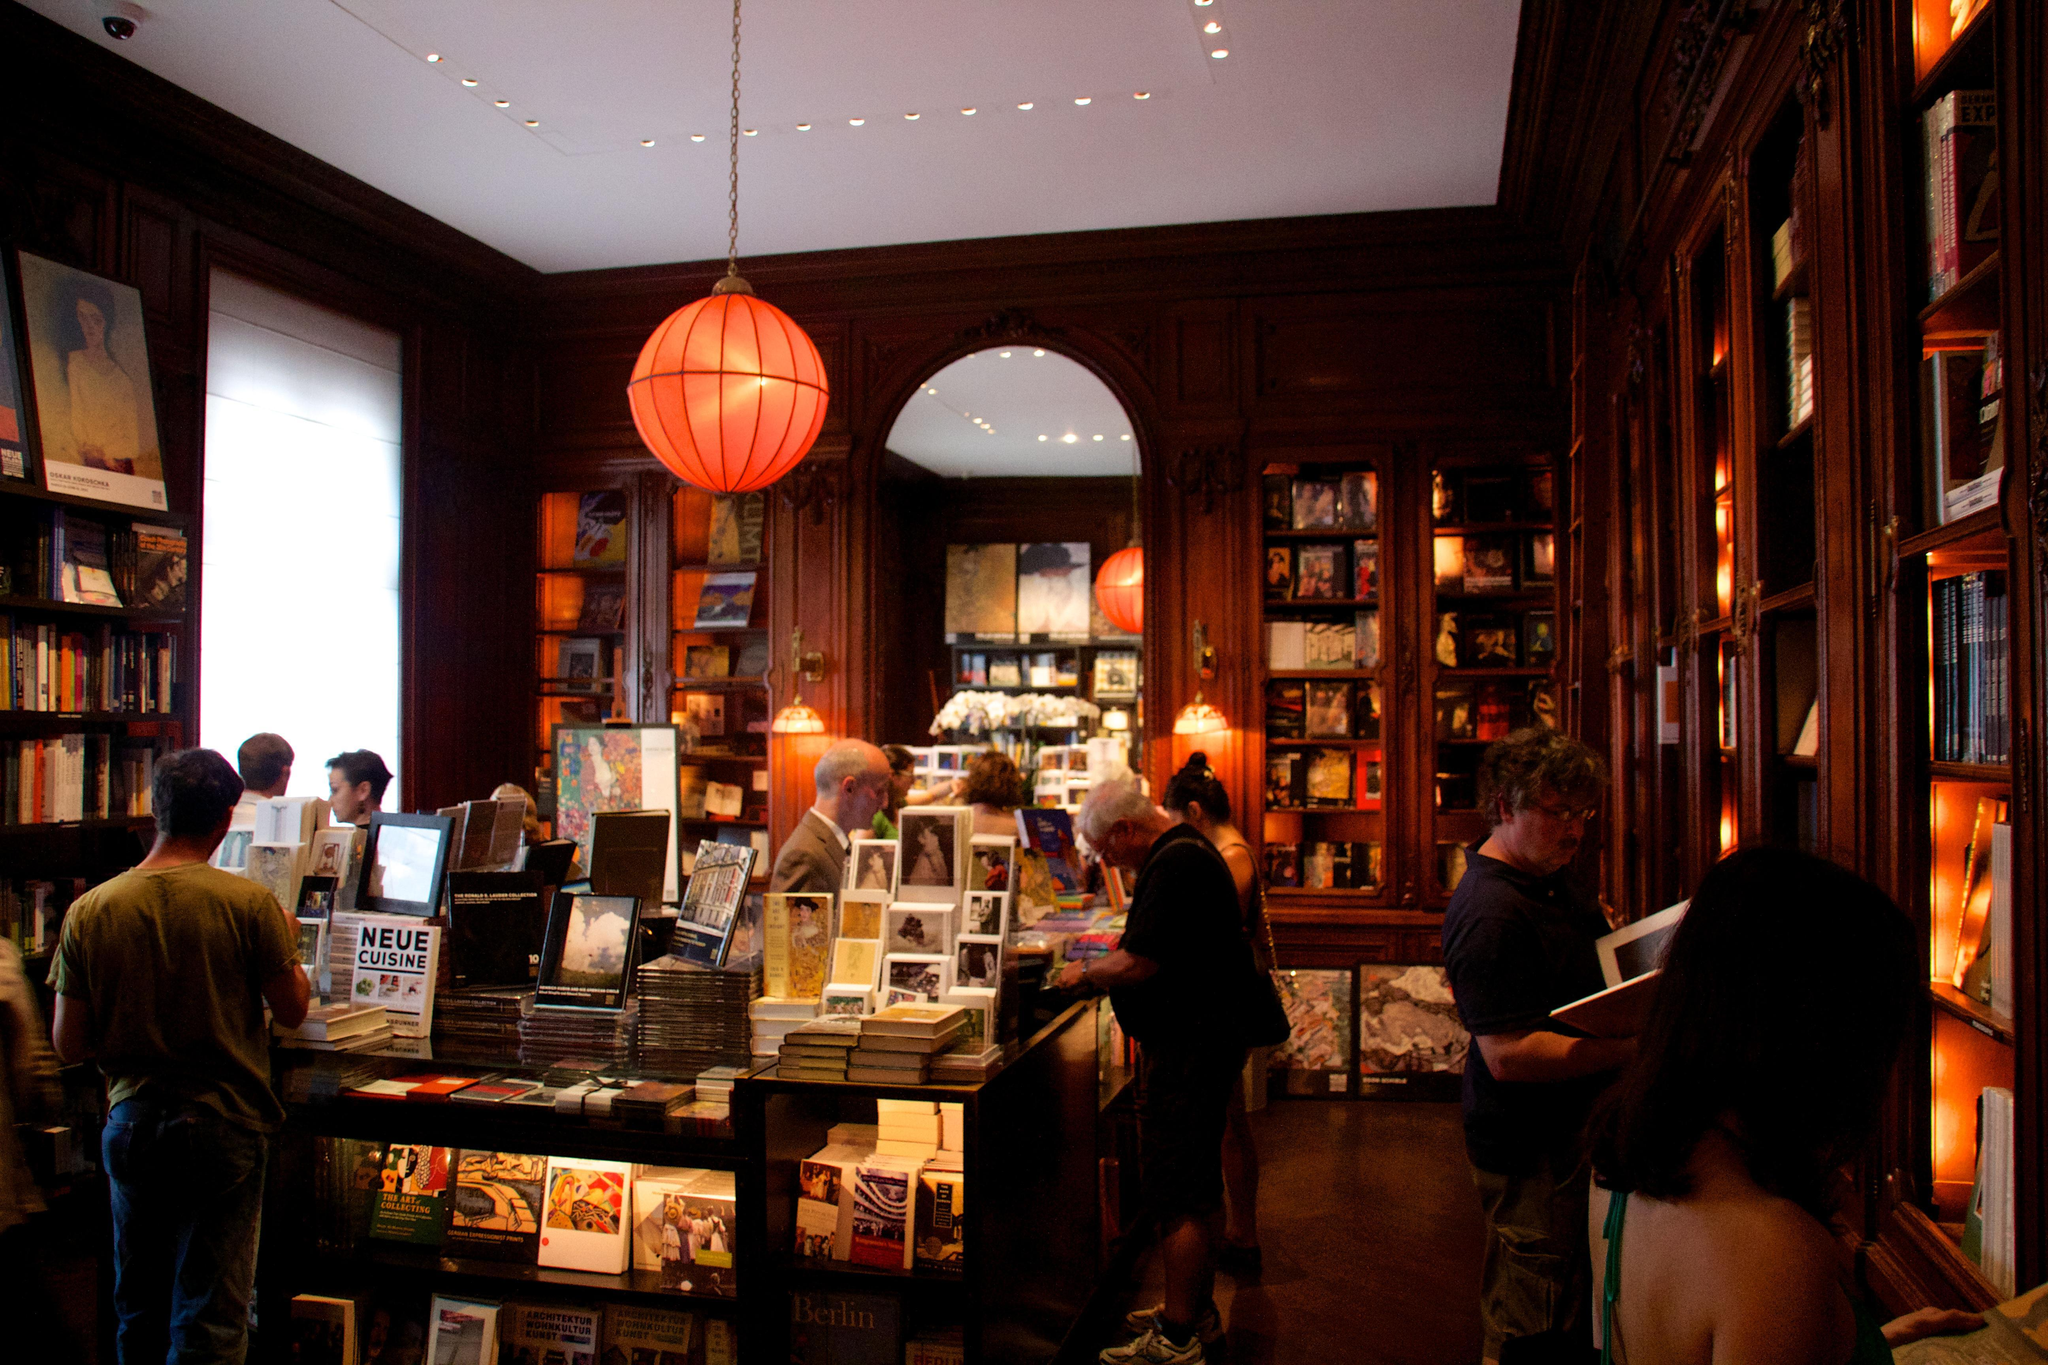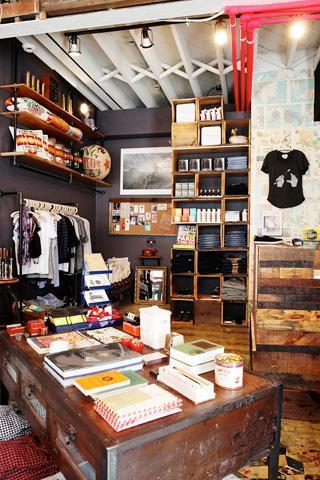The first image is the image on the left, the second image is the image on the right. Examine the images to the left and right. Is the description "In at least one image there are two bright orange ball lamps that are on hanging from the ceiling  of either side of an archway" accurate? Answer yes or no. Yes. The first image is the image on the left, the second image is the image on the right. For the images displayed, is the sentence "At least one image shows an orange ball hanging over a display case and in front of an arch in a room with no people in it." factually correct? Answer yes or no. Yes. 